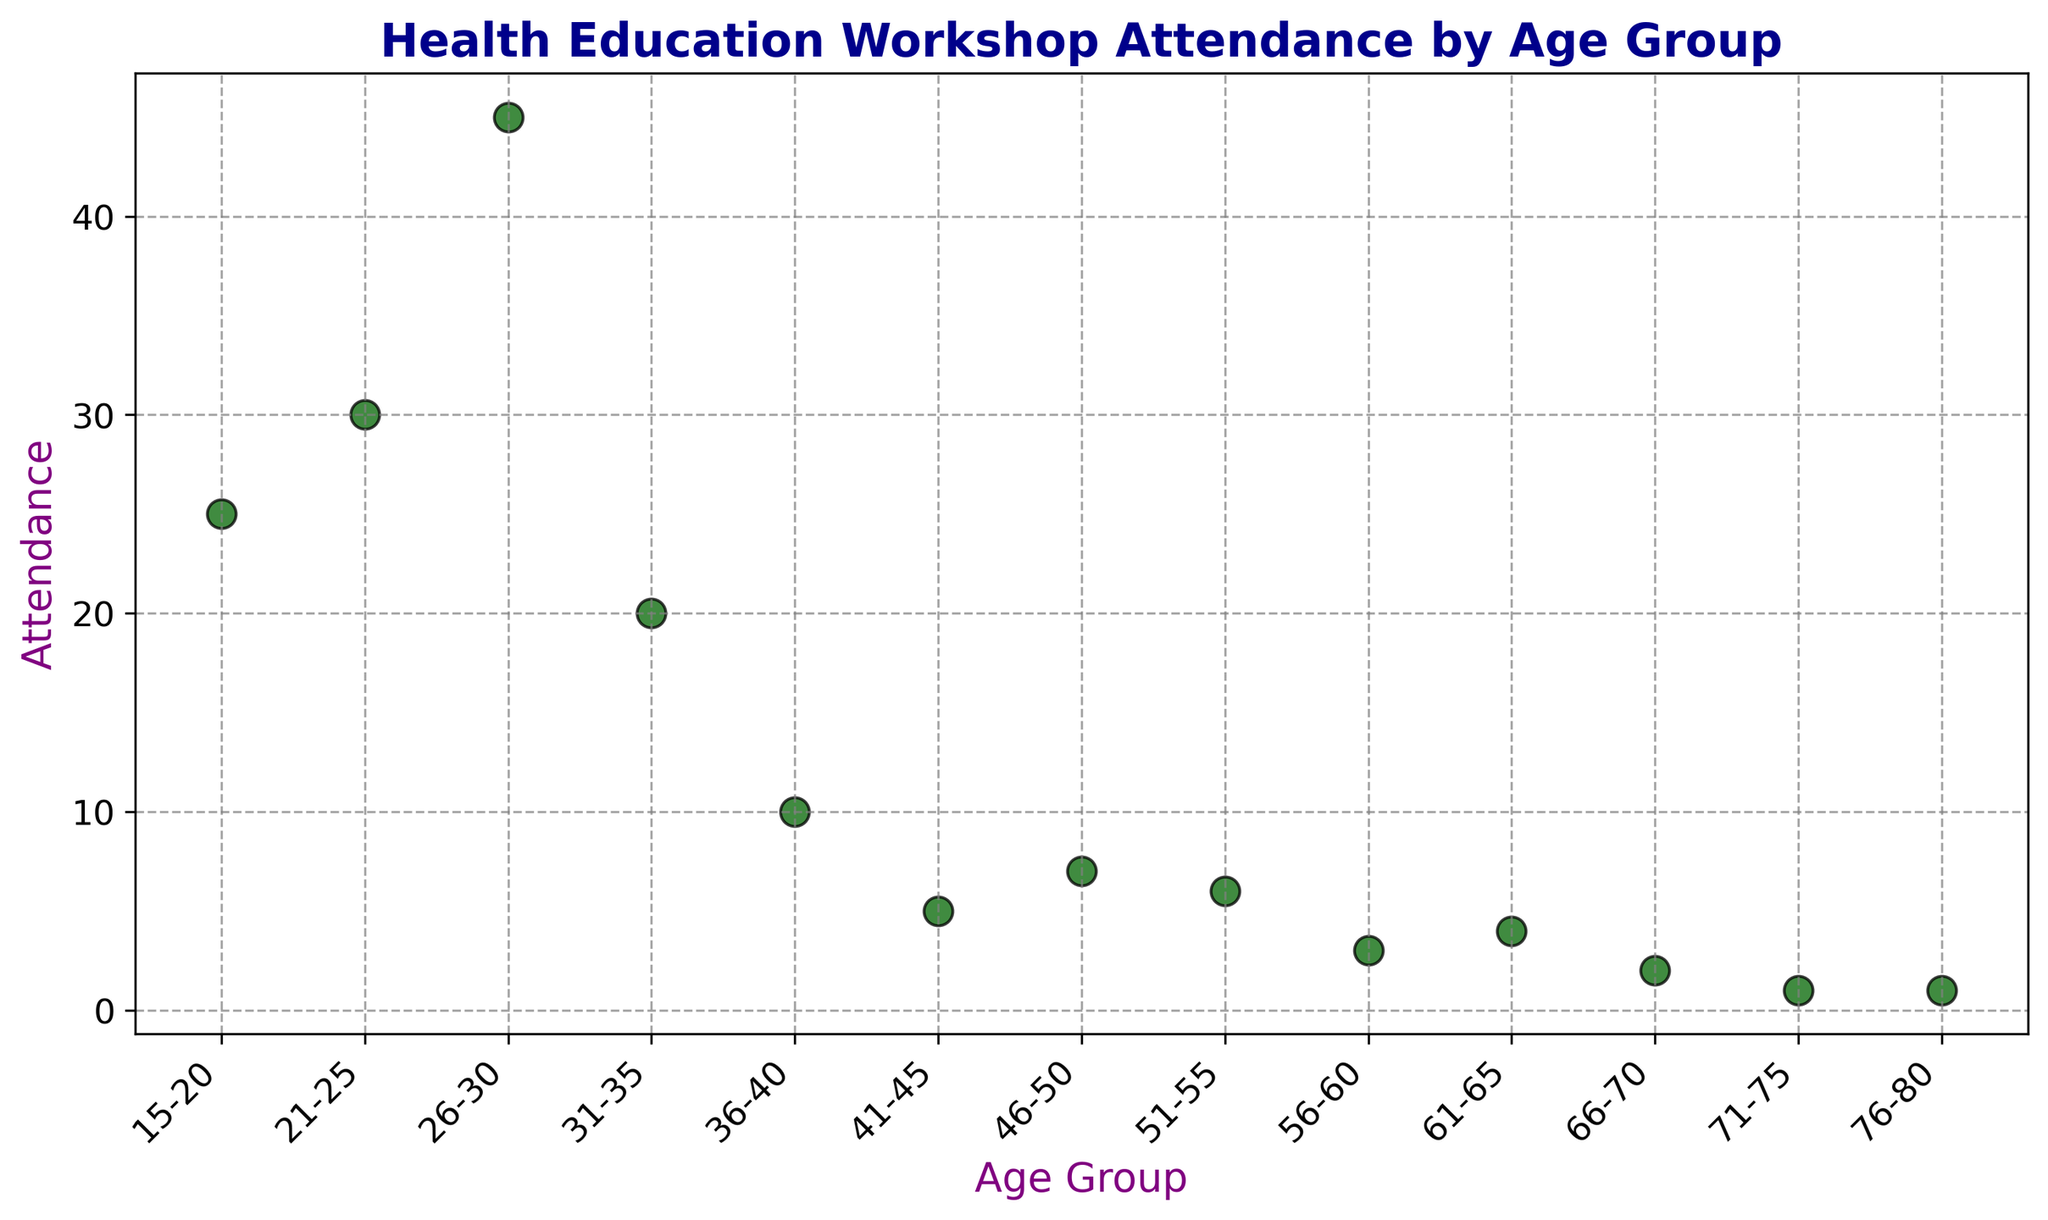What's the age group with the highest attendance? Look at the scatter plot and identify the point that is the highest on the y-axis (Attendance). The 26-30 age group has the highest attendance with a value of 45.
Answer: 26-30 What's the total attendance for individuals above the age of 50? Sum the attendance of the age groups 51-55, 56-60, 61-65, 66-70, 71-75, and 76-80. The values are 6, 3, 4, 2, 1, and 1, respectively, summing to 6 + 3 + 4 + 2 + 1 + 1 = 17.
Answer: 17 Which age groups have an attendance of less than 5? Observe the scatter plot to find the points with y-axis values less than 5. The age groups are 61-65 (4), 66-70 (2), 71-75 (1), and 76-80 (1).
Answer: 61-65, 66-70, 71-75, 76-80 How does the attendance of the 36-40 age group compare to the 41-45 age group? Check the scatter plot to see the y-axis values for these age groups. The 36-40 age group has an attendance of 10, while the 41-45 age group has an attendance of 5. 10 is greater than 5.
Answer: Greater What's the difference in attendance between the youngest age group and the oldest age group? Find the attendance values of the youngest age group (15-20) and the oldest age group (76-80), which are 25 and 1 respectively. The difference is 25 - 1 = 24.
Answer: 24 Which age groups participate more actively than the average attendance across all groups? First, calculate the average attendance by summing all attendance values and dividing by the number of age groups. The total attendance is 25 + 30 + 45 + 20 + 10 + 5 + 7 + 6 + 3 + 4 + 2 + 1 + 1 = 159 and there are 13 age groups, so the average is 159 / 13 ≈ 12.23. The age groups with attendance higher than 12.23 are 15-20 (25), 21-25 (30), and 26-30 (45).
Answer: 15-20, 21-25, 26-30 What is the trend of attendance with increasing age? Compare the attendance values across age groups from youngest to oldest in the scatter plot. The attendance generally decreases as age increases.
Answer: Decreasing 